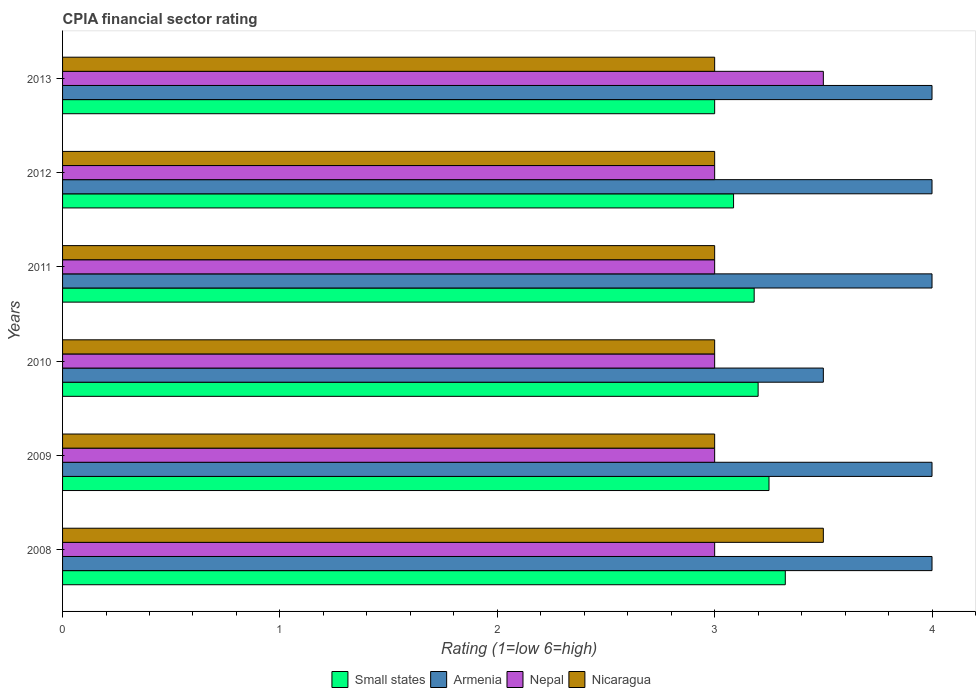How many bars are there on the 1st tick from the top?
Give a very brief answer. 4. What is the CPIA rating in Nicaragua in 2009?
Your answer should be compact. 3. Across all years, what is the maximum CPIA rating in Small states?
Make the answer very short. 3.33. In which year was the CPIA rating in Nicaragua maximum?
Your response must be concise. 2008. In which year was the CPIA rating in Nicaragua minimum?
Give a very brief answer. 2009. What is the total CPIA rating in Small states in the graph?
Make the answer very short. 19.04. What is the difference between the CPIA rating in Nepal in 2008 and the CPIA rating in Armenia in 2013?
Ensure brevity in your answer.  -1. What is the average CPIA rating in Armenia per year?
Make the answer very short. 3.92. What is the ratio of the CPIA rating in Small states in 2011 to that in 2012?
Offer a very short reply. 1.03. Is the CPIA rating in Nicaragua in 2009 less than that in 2013?
Your answer should be very brief. No. Is the difference between the CPIA rating in Nicaragua in 2008 and 2010 greater than the difference between the CPIA rating in Nepal in 2008 and 2010?
Your answer should be very brief. Yes. What is the difference between the highest and the second highest CPIA rating in Nicaragua?
Provide a short and direct response. 0.5. What is the difference between the highest and the lowest CPIA rating in Nepal?
Ensure brevity in your answer.  0.5. In how many years, is the CPIA rating in Nepal greater than the average CPIA rating in Nepal taken over all years?
Offer a very short reply. 1. Is the sum of the CPIA rating in Small states in 2008 and 2010 greater than the maximum CPIA rating in Nicaragua across all years?
Your answer should be very brief. Yes. What does the 3rd bar from the top in 2012 represents?
Provide a short and direct response. Armenia. What does the 2nd bar from the bottom in 2010 represents?
Your answer should be very brief. Armenia. Is it the case that in every year, the sum of the CPIA rating in Nepal and CPIA rating in Armenia is greater than the CPIA rating in Small states?
Keep it short and to the point. Yes. Are all the bars in the graph horizontal?
Provide a short and direct response. Yes. How many years are there in the graph?
Ensure brevity in your answer.  6. What is the difference between two consecutive major ticks on the X-axis?
Make the answer very short. 1. Does the graph contain any zero values?
Give a very brief answer. No. Does the graph contain grids?
Keep it short and to the point. No. Where does the legend appear in the graph?
Ensure brevity in your answer.  Bottom center. How are the legend labels stacked?
Your response must be concise. Horizontal. What is the title of the graph?
Your answer should be very brief. CPIA financial sector rating. Does "Kiribati" appear as one of the legend labels in the graph?
Provide a succinct answer. No. What is the label or title of the Y-axis?
Make the answer very short. Years. What is the Rating (1=low 6=high) of Small states in 2008?
Provide a succinct answer. 3.33. What is the Rating (1=low 6=high) in Armenia in 2008?
Your response must be concise. 4. What is the Rating (1=low 6=high) in Small states in 2009?
Keep it short and to the point. 3.25. What is the Rating (1=low 6=high) of Armenia in 2009?
Provide a short and direct response. 4. What is the Rating (1=low 6=high) of Nepal in 2009?
Make the answer very short. 3. What is the Rating (1=low 6=high) of Nicaragua in 2009?
Ensure brevity in your answer.  3. What is the Rating (1=low 6=high) in Armenia in 2010?
Your response must be concise. 3.5. What is the Rating (1=low 6=high) in Nepal in 2010?
Your answer should be very brief. 3. What is the Rating (1=low 6=high) in Nicaragua in 2010?
Your response must be concise. 3. What is the Rating (1=low 6=high) in Small states in 2011?
Provide a succinct answer. 3.18. What is the Rating (1=low 6=high) of Small states in 2012?
Provide a succinct answer. 3.09. What is the Rating (1=low 6=high) in Armenia in 2012?
Offer a terse response. 4. What is the Rating (1=low 6=high) in Nepal in 2012?
Your response must be concise. 3. What is the Rating (1=low 6=high) in Small states in 2013?
Keep it short and to the point. 3. What is the Rating (1=low 6=high) of Armenia in 2013?
Your response must be concise. 4. Across all years, what is the maximum Rating (1=low 6=high) of Small states?
Ensure brevity in your answer.  3.33. Across all years, what is the maximum Rating (1=low 6=high) of Nepal?
Provide a succinct answer. 3.5. Across all years, what is the minimum Rating (1=low 6=high) of Small states?
Give a very brief answer. 3. What is the total Rating (1=low 6=high) of Small states in the graph?
Your answer should be compact. 19.04. What is the total Rating (1=low 6=high) of Armenia in the graph?
Provide a short and direct response. 23.5. What is the total Rating (1=low 6=high) of Nicaragua in the graph?
Your answer should be compact. 18.5. What is the difference between the Rating (1=low 6=high) of Small states in 2008 and that in 2009?
Provide a short and direct response. 0.07. What is the difference between the Rating (1=low 6=high) in Small states in 2008 and that in 2010?
Offer a very short reply. 0.12. What is the difference between the Rating (1=low 6=high) of Nicaragua in 2008 and that in 2010?
Your answer should be very brief. 0.5. What is the difference between the Rating (1=low 6=high) in Small states in 2008 and that in 2011?
Your answer should be compact. 0.14. What is the difference between the Rating (1=low 6=high) of Armenia in 2008 and that in 2011?
Make the answer very short. 0. What is the difference between the Rating (1=low 6=high) in Nepal in 2008 and that in 2011?
Offer a very short reply. 0. What is the difference between the Rating (1=low 6=high) in Nicaragua in 2008 and that in 2011?
Give a very brief answer. 0.5. What is the difference between the Rating (1=low 6=high) in Small states in 2008 and that in 2012?
Ensure brevity in your answer.  0.24. What is the difference between the Rating (1=low 6=high) of Nicaragua in 2008 and that in 2012?
Offer a very short reply. 0.5. What is the difference between the Rating (1=low 6=high) in Small states in 2008 and that in 2013?
Ensure brevity in your answer.  0.33. What is the difference between the Rating (1=low 6=high) in Armenia in 2009 and that in 2010?
Offer a terse response. 0.5. What is the difference between the Rating (1=low 6=high) in Small states in 2009 and that in 2011?
Keep it short and to the point. 0.07. What is the difference between the Rating (1=low 6=high) in Nepal in 2009 and that in 2011?
Offer a very short reply. 0. What is the difference between the Rating (1=low 6=high) in Nicaragua in 2009 and that in 2011?
Your response must be concise. 0. What is the difference between the Rating (1=low 6=high) of Small states in 2009 and that in 2012?
Offer a very short reply. 0.16. What is the difference between the Rating (1=low 6=high) of Nepal in 2009 and that in 2012?
Offer a very short reply. 0. What is the difference between the Rating (1=low 6=high) in Nepal in 2009 and that in 2013?
Your response must be concise. -0.5. What is the difference between the Rating (1=low 6=high) in Nicaragua in 2009 and that in 2013?
Offer a terse response. 0. What is the difference between the Rating (1=low 6=high) of Small states in 2010 and that in 2011?
Offer a terse response. 0.02. What is the difference between the Rating (1=low 6=high) in Armenia in 2010 and that in 2011?
Provide a succinct answer. -0.5. What is the difference between the Rating (1=low 6=high) of Small states in 2010 and that in 2012?
Your response must be concise. 0.11. What is the difference between the Rating (1=low 6=high) in Nepal in 2010 and that in 2012?
Make the answer very short. 0. What is the difference between the Rating (1=low 6=high) in Nicaragua in 2010 and that in 2012?
Make the answer very short. 0. What is the difference between the Rating (1=low 6=high) in Small states in 2010 and that in 2013?
Give a very brief answer. 0.2. What is the difference between the Rating (1=low 6=high) in Armenia in 2010 and that in 2013?
Give a very brief answer. -0.5. What is the difference between the Rating (1=low 6=high) of Nepal in 2010 and that in 2013?
Give a very brief answer. -0.5. What is the difference between the Rating (1=low 6=high) in Nicaragua in 2010 and that in 2013?
Your response must be concise. 0. What is the difference between the Rating (1=low 6=high) in Small states in 2011 and that in 2012?
Provide a succinct answer. 0.09. What is the difference between the Rating (1=low 6=high) in Small states in 2011 and that in 2013?
Offer a very short reply. 0.18. What is the difference between the Rating (1=low 6=high) of Armenia in 2011 and that in 2013?
Your response must be concise. 0. What is the difference between the Rating (1=low 6=high) in Nepal in 2011 and that in 2013?
Provide a short and direct response. -0.5. What is the difference between the Rating (1=low 6=high) in Nicaragua in 2011 and that in 2013?
Your response must be concise. 0. What is the difference between the Rating (1=low 6=high) in Small states in 2012 and that in 2013?
Keep it short and to the point. 0.09. What is the difference between the Rating (1=low 6=high) in Nepal in 2012 and that in 2013?
Provide a short and direct response. -0.5. What is the difference between the Rating (1=low 6=high) in Nicaragua in 2012 and that in 2013?
Make the answer very short. 0. What is the difference between the Rating (1=low 6=high) of Small states in 2008 and the Rating (1=low 6=high) of Armenia in 2009?
Give a very brief answer. -0.68. What is the difference between the Rating (1=low 6=high) of Small states in 2008 and the Rating (1=low 6=high) of Nepal in 2009?
Your answer should be compact. 0.33. What is the difference between the Rating (1=low 6=high) in Small states in 2008 and the Rating (1=low 6=high) in Nicaragua in 2009?
Keep it short and to the point. 0.33. What is the difference between the Rating (1=low 6=high) in Armenia in 2008 and the Rating (1=low 6=high) in Nicaragua in 2009?
Your answer should be compact. 1. What is the difference between the Rating (1=low 6=high) in Nepal in 2008 and the Rating (1=low 6=high) in Nicaragua in 2009?
Provide a short and direct response. 0. What is the difference between the Rating (1=low 6=high) of Small states in 2008 and the Rating (1=low 6=high) of Armenia in 2010?
Your response must be concise. -0.17. What is the difference between the Rating (1=low 6=high) of Small states in 2008 and the Rating (1=low 6=high) of Nepal in 2010?
Ensure brevity in your answer.  0.33. What is the difference between the Rating (1=low 6=high) in Small states in 2008 and the Rating (1=low 6=high) in Nicaragua in 2010?
Your answer should be very brief. 0.33. What is the difference between the Rating (1=low 6=high) of Armenia in 2008 and the Rating (1=low 6=high) of Nicaragua in 2010?
Make the answer very short. 1. What is the difference between the Rating (1=low 6=high) in Nepal in 2008 and the Rating (1=low 6=high) in Nicaragua in 2010?
Your response must be concise. 0. What is the difference between the Rating (1=low 6=high) in Small states in 2008 and the Rating (1=low 6=high) in Armenia in 2011?
Your answer should be very brief. -0.68. What is the difference between the Rating (1=low 6=high) in Small states in 2008 and the Rating (1=low 6=high) in Nepal in 2011?
Give a very brief answer. 0.33. What is the difference between the Rating (1=low 6=high) of Small states in 2008 and the Rating (1=low 6=high) of Nicaragua in 2011?
Provide a short and direct response. 0.33. What is the difference between the Rating (1=low 6=high) in Armenia in 2008 and the Rating (1=low 6=high) in Nepal in 2011?
Your answer should be very brief. 1. What is the difference between the Rating (1=low 6=high) of Armenia in 2008 and the Rating (1=low 6=high) of Nicaragua in 2011?
Your answer should be very brief. 1. What is the difference between the Rating (1=low 6=high) in Small states in 2008 and the Rating (1=low 6=high) in Armenia in 2012?
Your response must be concise. -0.68. What is the difference between the Rating (1=low 6=high) in Small states in 2008 and the Rating (1=low 6=high) in Nepal in 2012?
Your answer should be compact. 0.33. What is the difference between the Rating (1=low 6=high) of Small states in 2008 and the Rating (1=low 6=high) of Nicaragua in 2012?
Provide a succinct answer. 0.33. What is the difference between the Rating (1=low 6=high) of Armenia in 2008 and the Rating (1=low 6=high) of Nicaragua in 2012?
Your response must be concise. 1. What is the difference between the Rating (1=low 6=high) of Small states in 2008 and the Rating (1=low 6=high) of Armenia in 2013?
Your answer should be compact. -0.68. What is the difference between the Rating (1=low 6=high) in Small states in 2008 and the Rating (1=low 6=high) in Nepal in 2013?
Provide a succinct answer. -0.17. What is the difference between the Rating (1=low 6=high) in Small states in 2008 and the Rating (1=low 6=high) in Nicaragua in 2013?
Offer a very short reply. 0.33. What is the difference between the Rating (1=low 6=high) of Armenia in 2008 and the Rating (1=low 6=high) of Nepal in 2013?
Ensure brevity in your answer.  0.5. What is the difference between the Rating (1=low 6=high) in Small states in 2009 and the Rating (1=low 6=high) in Armenia in 2010?
Ensure brevity in your answer.  -0.25. What is the difference between the Rating (1=low 6=high) of Armenia in 2009 and the Rating (1=low 6=high) of Nepal in 2010?
Provide a succinct answer. 1. What is the difference between the Rating (1=low 6=high) of Nepal in 2009 and the Rating (1=low 6=high) of Nicaragua in 2010?
Provide a succinct answer. 0. What is the difference between the Rating (1=low 6=high) of Small states in 2009 and the Rating (1=low 6=high) of Armenia in 2011?
Offer a terse response. -0.75. What is the difference between the Rating (1=low 6=high) of Small states in 2009 and the Rating (1=low 6=high) of Nicaragua in 2011?
Offer a very short reply. 0.25. What is the difference between the Rating (1=low 6=high) in Small states in 2009 and the Rating (1=low 6=high) in Armenia in 2012?
Ensure brevity in your answer.  -0.75. What is the difference between the Rating (1=low 6=high) in Small states in 2009 and the Rating (1=low 6=high) in Nicaragua in 2012?
Ensure brevity in your answer.  0.25. What is the difference between the Rating (1=low 6=high) in Armenia in 2009 and the Rating (1=low 6=high) in Nepal in 2012?
Give a very brief answer. 1. What is the difference between the Rating (1=low 6=high) in Armenia in 2009 and the Rating (1=low 6=high) in Nicaragua in 2012?
Give a very brief answer. 1. What is the difference between the Rating (1=low 6=high) of Nepal in 2009 and the Rating (1=low 6=high) of Nicaragua in 2012?
Ensure brevity in your answer.  0. What is the difference between the Rating (1=low 6=high) of Small states in 2009 and the Rating (1=low 6=high) of Armenia in 2013?
Offer a terse response. -0.75. What is the difference between the Rating (1=low 6=high) of Small states in 2009 and the Rating (1=low 6=high) of Nepal in 2013?
Keep it short and to the point. -0.25. What is the difference between the Rating (1=low 6=high) of Small states in 2009 and the Rating (1=low 6=high) of Nicaragua in 2013?
Your response must be concise. 0.25. What is the difference between the Rating (1=low 6=high) of Nepal in 2009 and the Rating (1=low 6=high) of Nicaragua in 2013?
Provide a succinct answer. 0. What is the difference between the Rating (1=low 6=high) in Small states in 2010 and the Rating (1=low 6=high) in Armenia in 2011?
Your answer should be compact. -0.8. What is the difference between the Rating (1=low 6=high) of Small states in 2010 and the Rating (1=low 6=high) of Nepal in 2012?
Keep it short and to the point. 0.2. What is the difference between the Rating (1=low 6=high) of Armenia in 2010 and the Rating (1=low 6=high) of Nepal in 2012?
Give a very brief answer. 0.5. What is the difference between the Rating (1=low 6=high) in Armenia in 2010 and the Rating (1=low 6=high) in Nicaragua in 2012?
Provide a short and direct response. 0.5. What is the difference between the Rating (1=low 6=high) of Small states in 2010 and the Rating (1=low 6=high) of Nepal in 2013?
Keep it short and to the point. -0.3. What is the difference between the Rating (1=low 6=high) in Armenia in 2010 and the Rating (1=low 6=high) in Nepal in 2013?
Your answer should be very brief. 0. What is the difference between the Rating (1=low 6=high) in Armenia in 2010 and the Rating (1=low 6=high) in Nicaragua in 2013?
Keep it short and to the point. 0.5. What is the difference between the Rating (1=low 6=high) in Nepal in 2010 and the Rating (1=low 6=high) in Nicaragua in 2013?
Make the answer very short. 0. What is the difference between the Rating (1=low 6=high) in Small states in 2011 and the Rating (1=low 6=high) in Armenia in 2012?
Your answer should be very brief. -0.82. What is the difference between the Rating (1=low 6=high) of Small states in 2011 and the Rating (1=low 6=high) of Nepal in 2012?
Ensure brevity in your answer.  0.18. What is the difference between the Rating (1=low 6=high) of Small states in 2011 and the Rating (1=low 6=high) of Nicaragua in 2012?
Keep it short and to the point. 0.18. What is the difference between the Rating (1=low 6=high) of Small states in 2011 and the Rating (1=low 6=high) of Armenia in 2013?
Keep it short and to the point. -0.82. What is the difference between the Rating (1=low 6=high) in Small states in 2011 and the Rating (1=low 6=high) in Nepal in 2013?
Your answer should be compact. -0.32. What is the difference between the Rating (1=low 6=high) of Small states in 2011 and the Rating (1=low 6=high) of Nicaragua in 2013?
Your answer should be very brief. 0.18. What is the difference between the Rating (1=low 6=high) in Armenia in 2011 and the Rating (1=low 6=high) in Nepal in 2013?
Offer a terse response. 0.5. What is the difference between the Rating (1=low 6=high) in Nepal in 2011 and the Rating (1=low 6=high) in Nicaragua in 2013?
Keep it short and to the point. 0. What is the difference between the Rating (1=low 6=high) of Small states in 2012 and the Rating (1=low 6=high) of Armenia in 2013?
Make the answer very short. -0.91. What is the difference between the Rating (1=low 6=high) of Small states in 2012 and the Rating (1=low 6=high) of Nepal in 2013?
Keep it short and to the point. -0.41. What is the difference between the Rating (1=low 6=high) of Small states in 2012 and the Rating (1=low 6=high) of Nicaragua in 2013?
Offer a terse response. 0.09. What is the average Rating (1=low 6=high) in Small states per year?
Make the answer very short. 3.17. What is the average Rating (1=low 6=high) in Armenia per year?
Offer a terse response. 3.92. What is the average Rating (1=low 6=high) of Nepal per year?
Your response must be concise. 3.08. What is the average Rating (1=low 6=high) of Nicaragua per year?
Your answer should be compact. 3.08. In the year 2008, what is the difference between the Rating (1=low 6=high) in Small states and Rating (1=low 6=high) in Armenia?
Your answer should be very brief. -0.68. In the year 2008, what is the difference between the Rating (1=low 6=high) in Small states and Rating (1=low 6=high) in Nepal?
Provide a succinct answer. 0.33. In the year 2008, what is the difference between the Rating (1=low 6=high) in Small states and Rating (1=low 6=high) in Nicaragua?
Ensure brevity in your answer.  -0.17. In the year 2008, what is the difference between the Rating (1=low 6=high) of Armenia and Rating (1=low 6=high) of Nicaragua?
Ensure brevity in your answer.  0.5. In the year 2008, what is the difference between the Rating (1=low 6=high) in Nepal and Rating (1=low 6=high) in Nicaragua?
Your answer should be very brief. -0.5. In the year 2009, what is the difference between the Rating (1=low 6=high) of Small states and Rating (1=low 6=high) of Armenia?
Give a very brief answer. -0.75. In the year 2009, what is the difference between the Rating (1=low 6=high) of Armenia and Rating (1=low 6=high) of Nicaragua?
Provide a succinct answer. 1. In the year 2009, what is the difference between the Rating (1=low 6=high) in Nepal and Rating (1=low 6=high) in Nicaragua?
Provide a short and direct response. 0. In the year 2010, what is the difference between the Rating (1=low 6=high) in Small states and Rating (1=low 6=high) in Armenia?
Your response must be concise. -0.3. In the year 2010, what is the difference between the Rating (1=low 6=high) in Small states and Rating (1=low 6=high) in Nicaragua?
Your answer should be very brief. 0.2. In the year 2011, what is the difference between the Rating (1=low 6=high) of Small states and Rating (1=low 6=high) of Armenia?
Give a very brief answer. -0.82. In the year 2011, what is the difference between the Rating (1=low 6=high) in Small states and Rating (1=low 6=high) in Nepal?
Give a very brief answer. 0.18. In the year 2011, what is the difference between the Rating (1=low 6=high) of Small states and Rating (1=low 6=high) of Nicaragua?
Provide a short and direct response. 0.18. In the year 2011, what is the difference between the Rating (1=low 6=high) in Armenia and Rating (1=low 6=high) in Nepal?
Offer a terse response. 1. In the year 2011, what is the difference between the Rating (1=low 6=high) in Armenia and Rating (1=low 6=high) in Nicaragua?
Ensure brevity in your answer.  1. In the year 2012, what is the difference between the Rating (1=low 6=high) in Small states and Rating (1=low 6=high) in Armenia?
Ensure brevity in your answer.  -0.91. In the year 2012, what is the difference between the Rating (1=low 6=high) of Small states and Rating (1=low 6=high) of Nepal?
Make the answer very short. 0.09. In the year 2012, what is the difference between the Rating (1=low 6=high) of Small states and Rating (1=low 6=high) of Nicaragua?
Your answer should be compact. 0.09. In the year 2012, what is the difference between the Rating (1=low 6=high) in Armenia and Rating (1=low 6=high) in Nepal?
Make the answer very short. 1. In the year 2012, what is the difference between the Rating (1=low 6=high) in Armenia and Rating (1=low 6=high) in Nicaragua?
Your response must be concise. 1. In the year 2012, what is the difference between the Rating (1=low 6=high) in Nepal and Rating (1=low 6=high) in Nicaragua?
Your answer should be compact. 0. In the year 2013, what is the difference between the Rating (1=low 6=high) in Small states and Rating (1=low 6=high) in Armenia?
Provide a short and direct response. -1. In the year 2013, what is the difference between the Rating (1=low 6=high) in Small states and Rating (1=low 6=high) in Nicaragua?
Offer a terse response. 0. In the year 2013, what is the difference between the Rating (1=low 6=high) of Nepal and Rating (1=low 6=high) of Nicaragua?
Keep it short and to the point. 0.5. What is the ratio of the Rating (1=low 6=high) of Small states in 2008 to that in 2009?
Your answer should be very brief. 1.02. What is the ratio of the Rating (1=low 6=high) of Armenia in 2008 to that in 2009?
Make the answer very short. 1. What is the ratio of the Rating (1=low 6=high) in Nepal in 2008 to that in 2009?
Keep it short and to the point. 1. What is the ratio of the Rating (1=low 6=high) in Nicaragua in 2008 to that in 2009?
Your answer should be very brief. 1.17. What is the ratio of the Rating (1=low 6=high) in Small states in 2008 to that in 2010?
Provide a succinct answer. 1.04. What is the ratio of the Rating (1=low 6=high) of Armenia in 2008 to that in 2010?
Offer a terse response. 1.14. What is the ratio of the Rating (1=low 6=high) of Small states in 2008 to that in 2011?
Keep it short and to the point. 1.04. What is the ratio of the Rating (1=low 6=high) of Armenia in 2008 to that in 2011?
Provide a short and direct response. 1. What is the ratio of the Rating (1=low 6=high) of Nepal in 2008 to that in 2011?
Provide a succinct answer. 1. What is the ratio of the Rating (1=low 6=high) in Small states in 2008 to that in 2012?
Provide a succinct answer. 1.08. What is the ratio of the Rating (1=low 6=high) of Nepal in 2008 to that in 2012?
Provide a succinct answer. 1. What is the ratio of the Rating (1=low 6=high) of Nicaragua in 2008 to that in 2012?
Make the answer very short. 1.17. What is the ratio of the Rating (1=low 6=high) of Small states in 2008 to that in 2013?
Offer a very short reply. 1.11. What is the ratio of the Rating (1=low 6=high) in Small states in 2009 to that in 2010?
Provide a succinct answer. 1.02. What is the ratio of the Rating (1=low 6=high) of Nicaragua in 2009 to that in 2010?
Give a very brief answer. 1. What is the ratio of the Rating (1=low 6=high) of Small states in 2009 to that in 2011?
Offer a terse response. 1.02. What is the ratio of the Rating (1=low 6=high) of Armenia in 2009 to that in 2011?
Give a very brief answer. 1. What is the ratio of the Rating (1=low 6=high) in Nepal in 2009 to that in 2011?
Ensure brevity in your answer.  1. What is the ratio of the Rating (1=low 6=high) in Small states in 2009 to that in 2012?
Ensure brevity in your answer.  1.05. What is the ratio of the Rating (1=low 6=high) of Armenia in 2009 to that in 2012?
Your response must be concise. 1. What is the ratio of the Rating (1=low 6=high) in Small states in 2009 to that in 2013?
Ensure brevity in your answer.  1.08. What is the ratio of the Rating (1=low 6=high) in Armenia in 2009 to that in 2013?
Offer a very short reply. 1. What is the ratio of the Rating (1=low 6=high) of Nepal in 2009 to that in 2013?
Ensure brevity in your answer.  0.86. What is the ratio of the Rating (1=low 6=high) in Small states in 2010 to that in 2011?
Offer a very short reply. 1.01. What is the ratio of the Rating (1=low 6=high) of Nicaragua in 2010 to that in 2011?
Provide a succinct answer. 1. What is the ratio of the Rating (1=low 6=high) of Small states in 2010 to that in 2012?
Keep it short and to the point. 1.04. What is the ratio of the Rating (1=low 6=high) of Armenia in 2010 to that in 2012?
Give a very brief answer. 0.88. What is the ratio of the Rating (1=low 6=high) of Small states in 2010 to that in 2013?
Provide a short and direct response. 1.07. What is the ratio of the Rating (1=low 6=high) of Small states in 2011 to that in 2012?
Make the answer very short. 1.03. What is the ratio of the Rating (1=low 6=high) in Small states in 2011 to that in 2013?
Offer a terse response. 1.06. What is the ratio of the Rating (1=low 6=high) in Nepal in 2011 to that in 2013?
Your answer should be compact. 0.86. What is the ratio of the Rating (1=low 6=high) in Nicaragua in 2011 to that in 2013?
Give a very brief answer. 1. What is the ratio of the Rating (1=low 6=high) of Small states in 2012 to that in 2013?
Keep it short and to the point. 1.03. What is the ratio of the Rating (1=low 6=high) in Armenia in 2012 to that in 2013?
Give a very brief answer. 1. What is the ratio of the Rating (1=low 6=high) of Nepal in 2012 to that in 2013?
Your response must be concise. 0.86. What is the difference between the highest and the second highest Rating (1=low 6=high) in Small states?
Your answer should be very brief. 0.07. What is the difference between the highest and the second highest Rating (1=low 6=high) of Armenia?
Give a very brief answer. 0. What is the difference between the highest and the second highest Rating (1=low 6=high) in Nepal?
Offer a terse response. 0.5. What is the difference between the highest and the second highest Rating (1=low 6=high) in Nicaragua?
Make the answer very short. 0.5. What is the difference between the highest and the lowest Rating (1=low 6=high) of Small states?
Your response must be concise. 0.33. What is the difference between the highest and the lowest Rating (1=low 6=high) of Nepal?
Your answer should be compact. 0.5. 